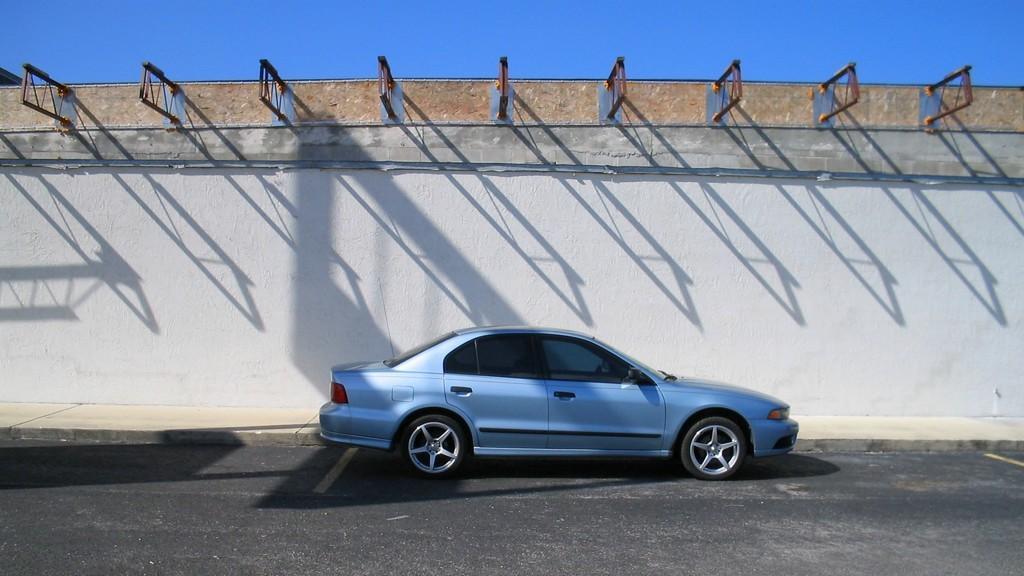How would you summarize this image in a sentence or two? In the image there is a car moving beside a wall and the car is of blue color. 